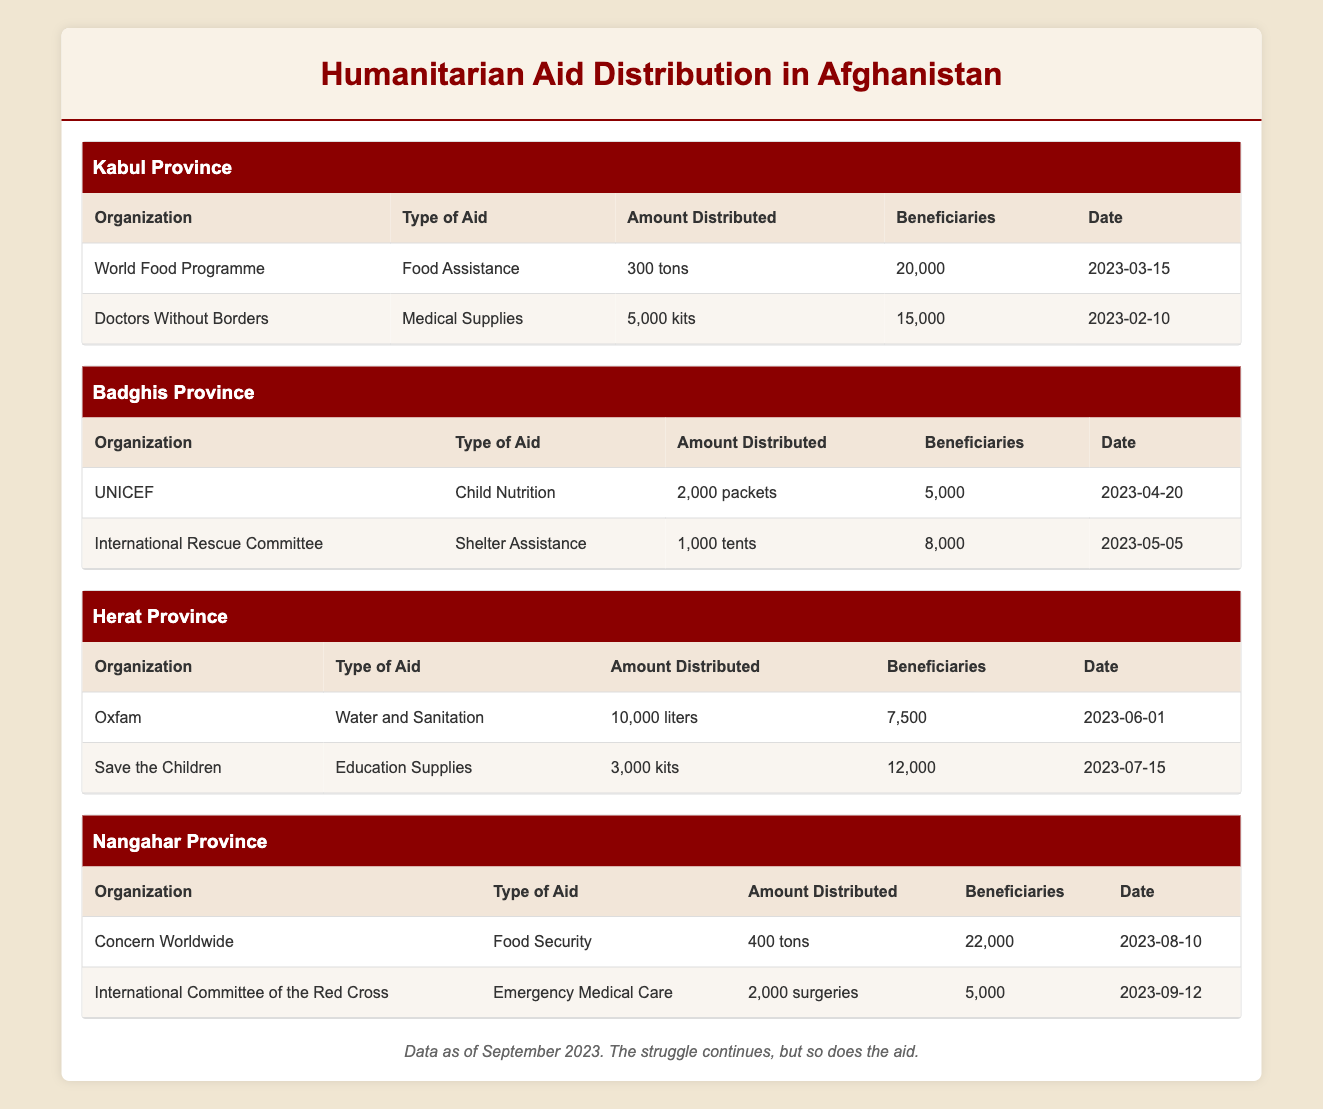What types of aid were provided in Badghis Province? The table lists two organizations that provided aid in Badghis Province: UNICEF, which delivered Child Nutrition, and the International Rescue Committee, which offered Shelter Assistance.
Answer: Child Nutrition and Shelter Assistance Which organization distributed the most amount of aid in Kabul? The two organizations listed in Kabul are the World Food Programme, which distributed 300 tons of food assistance, and Doctors Without Borders, which distributed 5,000 kits of medical supplies. The World Food Programme provided the larger amount.
Answer: World Food Programme How many total beneficiaries received aid from all organizations in Nangahar? The two organizations in Nangahar are Concern Worldwide, which helped 22,000 beneficiaries, and the International Committee of the Red Cross, which assisted 5,000 beneficiaries. By adding these two numbers together, 22,000 + 5,000 = 27,000.
Answer: 27,000 Did the amount of food assistance in Kabul exceed that in Nangahar? In Kabul, the World Food Programme distributed 300 tons of food assistance, while in Nangahar, Concern Worldwide distributed 400 tons. Since 300 is less than 400, the answer is no.
Answer: No What is the total number of beneficiaries across all provinces listed? To find the total number of beneficiaries, we need to add the beneficiaries from each province: Kabul (20,000 + 15,000), Badghis (5,000 + 8,000), Herat (7,500 + 12,000), and Nangahar (22,000 + 5,000). The calculations yield: Kabul: 35,000, Badghis: 13,000, Herat: 19,500, Nangahar: 27,000. Adding these totals gives: 35,000 + 13,000 + 19,500 + 27,000 = 94,500.
Answer: 94,500 Which organization delivered emergency medical care and how many surgeries were provided? The table indicates that the International Committee of the Red Cross delivered emergency medical care and they provided 2,000 surgeries.
Answer: International Committee of the Red Cross, 2,000 surgeries 